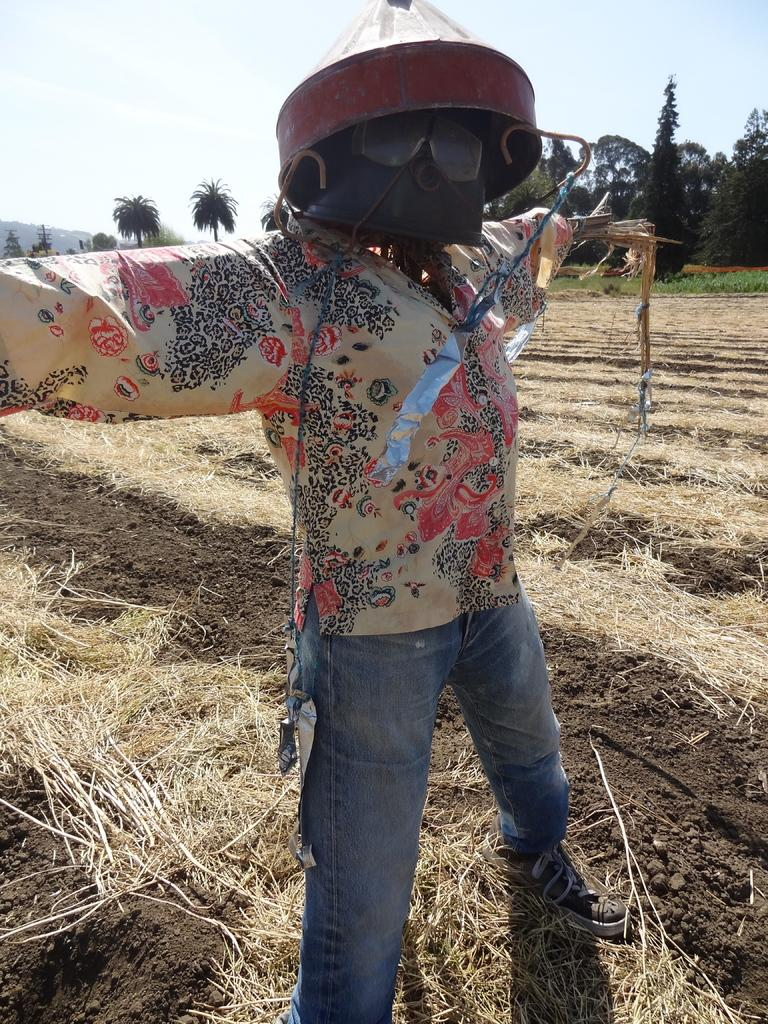What is the main subject in the image? There is a scarecrow in the image. What is the ground covered with in the image? Dry grass is visible on the ground. What can be seen in the background of the image? There are many trees in the background of the image. What is visible at the top of the image? The sky is visible at the top of the image. How does the scarecrow smash the steam in the image? There is no steam present in the image, and the scarecrow does not smash anything. 